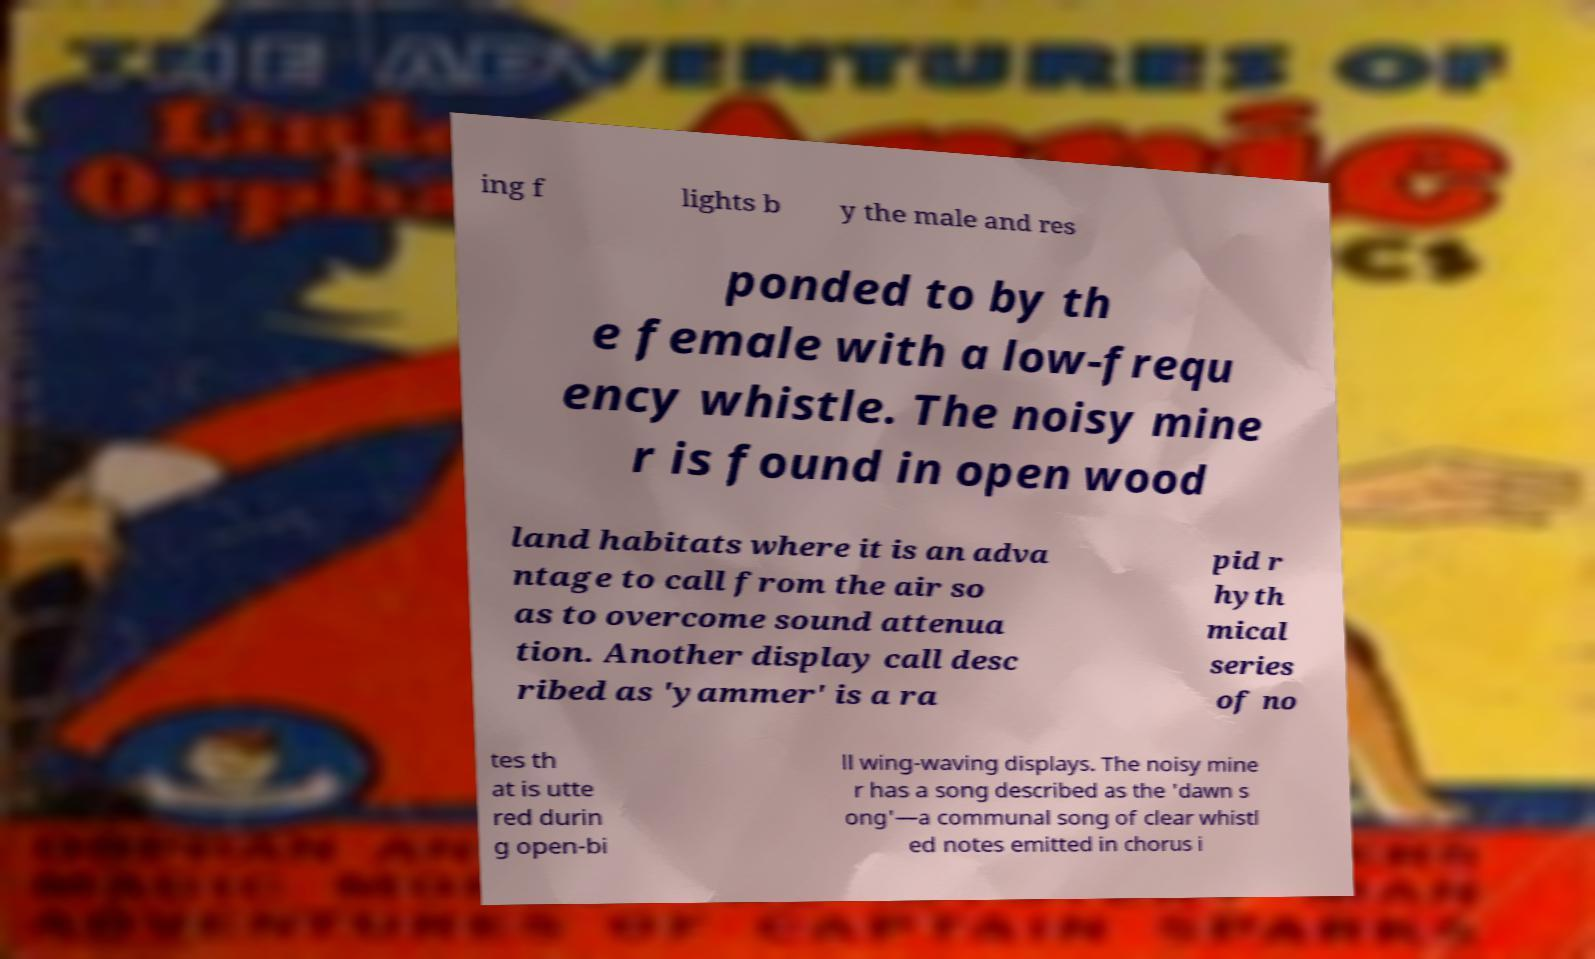I need the written content from this picture converted into text. Can you do that? ing f lights b y the male and res ponded to by th e female with a low-frequ ency whistle. The noisy mine r is found in open wood land habitats where it is an adva ntage to call from the air so as to overcome sound attenua tion. Another display call desc ribed as 'yammer' is a ra pid r hyth mical series of no tes th at is utte red durin g open-bi ll wing-waving displays. The noisy mine r has a song described as the 'dawn s ong'—a communal song of clear whistl ed notes emitted in chorus i 